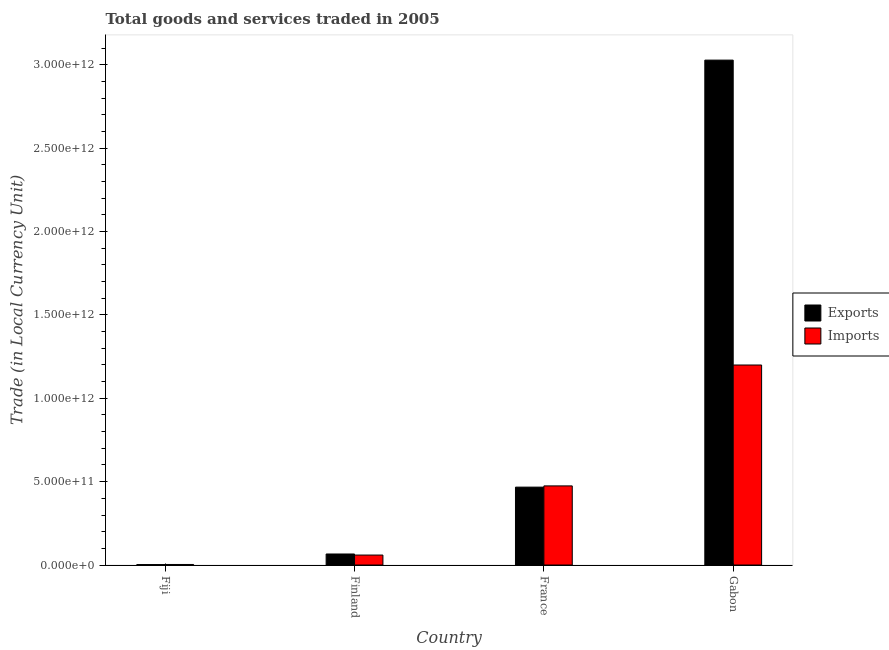Are the number of bars per tick equal to the number of legend labels?
Provide a succinct answer. Yes. Are the number of bars on each tick of the X-axis equal?
Give a very brief answer. Yes. How many bars are there on the 4th tick from the left?
Your answer should be compact. 2. How many bars are there on the 3rd tick from the right?
Your answer should be compact. 2. What is the label of the 4th group of bars from the left?
Your response must be concise. Gabon. In how many cases, is the number of bars for a given country not equal to the number of legend labels?
Make the answer very short. 0. What is the imports of goods and services in Finland?
Your answer should be compact. 5.98e+1. Across all countries, what is the maximum imports of goods and services?
Your answer should be compact. 1.20e+12. Across all countries, what is the minimum imports of goods and services?
Provide a succinct answer. 3.31e+09. In which country was the export of goods and services maximum?
Provide a short and direct response. Gabon. In which country was the export of goods and services minimum?
Your answer should be very brief. Fiji. What is the total imports of goods and services in the graph?
Provide a succinct answer. 1.74e+12. What is the difference between the imports of goods and services in Fiji and that in Gabon?
Your answer should be very brief. -1.20e+12. What is the difference between the export of goods and services in Gabon and the imports of goods and services in Finland?
Your response must be concise. 2.97e+12. What is the average export of goods and services per country?
Keep it short and to the point. 8.91e+11. What is the difference between the export of goods and services and imports of goods and services in Fiji?
Your answer should be compact. -6.10e+08. In how many countries, is the imports of goods and services greater than 1800000000000 LCU?
Make the answer very short. 0. What is the ratio of the export of goods and services in France to that in Gabon?
Give a very brief answer. 0.15. What is the difference between the highest and the second highest export of goods and services?
Make the answer very short. 2.56e+12. What is the difference between the highest and the lowest imports of goods and services?
Make the answer very short. 1.20e+12. What does the 1st bar from the left in Finland represents?
Offer a terse response. Exports. What does the 2nd bar from the right in Gabon represents?
Your answer should be very brief. Exports. How many bars are there?
Make the answer very short. 8. Are all the bars in the graph horizontal?
Keep it short and to the point. No. What is the difference between two consecutive major ticks on the Y-axis?
Give a very brief answer. 5.00e+11. Are the values on the major ticks of Y-axis written in scientific E-notation?
Your answer should be compact. Yes. Does the graph contain any zero values?
Provide a short and direct response. No. Does the graph contain grids?
Provide a succinct answer. No. Where does the legend appear in the graph?
Your answer should be very brief. Center right. How many legend labels are there?
Keep it short and to the point. 2. What is the title of the graph?
Provide a short and direct response. Total goods and services traded in 2005. Does "Domestic liabilities" appear as one of the legend labels in the graph?
Make the answer very short. No. What is the label or title of the X-axis?
Provide a succinct answer. Country. What is the label or title of the Y-axis?
Your answer should be very brief. Trade (in Local Currency Unit). What is the Trade (in Local Currency Unit) of Exports in Fiji?
Make the answer very short. 2.70e+09. What is the Trade (in Local Currency Unit) in Imports in Fiji?
Provide a short and direct response. 3.31e+09. What is the Trade (in Local Currency Unit) of Exports in Finland?
Keep it short and to the point. 6.62e+1. What is the Trade (in Local Currency Unit) in Imports in Finland?
Give a very brief answer. 5.98e+1. What is the Trade (in Local Currency Unit) of Exports in France?
Provide a succinct answer. 4.67e+11. What is the Trade (in Local Currency Unit) in Imports in France?
Ensure brevity in your answer.  4.75e+11. What is the Trade (in Local Currency Unit) of Exports in Gabon?
Your answer should be compact. 3.03e+12. What is the Trade (in Local Currency Unit) of Imports in Gabon?
Provide a short and direct response. 1.20e+12. Across all countries, what is the maximum Trade (in Local Currency Unit) in Exports?
Keep it short and to the point. 3.03e+12. Across all countries, what is the maximum Trade (in Local Currency Unit) in Imports?
Your answer should be compact. 1.20e+12. Across all countries, what is the minimum Trade (in Local Currency Unit) of Exports?
Ensure brevity in your answer.  2.70e+09. Across all countries, what is the minimum Trade (in Local Currency Unit) of Imports?
Make the answer very short. 3.31e+09. What is the total Trade (in Local Currency Unit) of Exports in the graph?
Keep it short and to the point. 3.56e+12. What is the total Trade (in Local Currency Unit) in Imports in the graph?
Your answer should be very brief. 1.74e+12. What is the difference between the Trade (in Local Currency Unit) of Exports in Fiji and that in Finland?
Offer a very short reply. -6.35e+1. What is the difference between the Trade (in Local Currency Unit) of Imports in Fiji and that in Finland?
Your answer should be very brief. -5.65e+1. What is the difference between the Trade (in Local Currency Unit) in Exports in Fiji and that in France?
Your answer should be compact. -4.65e+11. What is the difference between the Trade (in Local Currency Unit) of Imports in Fiji and that in France?
Provide a succinct answer. -4.71e+11. What is the difference between the Trade (in Local Currency Unit) of Exports in Fiji and that in Gabon?
Offer a very short reply. -3.03e+12. What is the difference between the Trade (in Local Currency Unit) in Imports in Fiji and that in Gabon?
Your answer should be compact. -1.20e+12. What is the difference between the Trade (in Local Currency Unit) in Exports in Finland and that in France?
Your answer should be compact. -4.01e+11. What is the difference between the Trade (in Local Currency Unit) in Imports in Finland and that in France?
Give a very brief answer. -4.15e+11. What is the difference between the Trade (in Local Currency Unit) of Exports in Finland and that in Gabon?
Provide a short and direct response. -2.96e+12. What is the difference between the Trade (in Local Currency Unit) in Imports in Finland and that in Gabon?
Provide a succinct answer. -1.14e+12. What is the difference between the Trade (in Local Currency Unit) in Exports in France and that in Gabon?
Your answer should be compact. -2.56e+12. What is the difference between the Trade (in Local Currency Unit) in Imports in France and that in Gabon?
Make the answer very short. -7.25e+11. What is the difference between the Trade (in Local Currency Unit) of Exports in Fiji and the Trade (in Local Currency Unit) of Imports in Finland?
Your response must be concise. -5.71e+1. What is the difference between the Trade (in Local Currency Unit) in Exports in Fiji and the Trade (in Local Currency Unit) in Imports in France?
Offer a terse response. -4.72e+11. What is the difference between the Trade (in Local Currency Unit) in Exports in Fiji and the Trade (in Local Currency Unit) in Imports in Gabon?
Your answer should be very brief. -1.20e+12. What is the difference between the Trade (in Local Currency Unit) of Exports in Finland and the Trade (in Local Currency Unit) of Imports in France?
Give a very brief answer. -4.08e+11. What is the difference between the Trade (in Local Currency Unit) in Exports in Finland and the Trade (in Local Currency Unit) in Imports in Gabon?
Provide a short and direct response. -1.13e+12. What is the difference between the Trade (in Local Currency Unit) in Exports in France and the Trade (in Local Currency Unit) in Imports in Gabon?
Provide a succinct answer. -7.33e+11. What is the average Trade (in Local Currency Unit) of Exports per country?
Make the answer very short. 8.91e+11. What is the average Trade (in Local Currency Unit) in Imports per country?
Give a very brief answer. 4.34e+11. What is the difference between the Trade (in Local Currency Unit) of Exports and Trade (in Local Currency Unit) of Imports in Fiji?
Offer a terse response. -6.10e+08. What is the difference between the Trade (in Local Currency Unit) of Exports and Trade (in Local Currency Unit) of Imports in Finland?
Make the answer very short. 6.38e+09. What is the difference between the Trade (in Local Currency Unit) of Exports and Trade (in Local Currency Unit) of Imports in France?
Your response must be concise. -7.34e+09. What is the difference between the Trade (in Local Currency Unit) of Exports and Trade (in Local Currency Unit) of Imports in Gabon?
Offer a very short reply. 1.83e+12. What is the ratio of the Trade (in Local Currency Unit) of Exports in Fiji to that in Finland?
Make the answer very short. 0.04. What is the ratio of the Trade (in Local Currency Unit) in Imports in Fiji to that in Finland?
Offer a very short reply. 0.06. What is the ratio of the Trade (in Local Currency Unit) of Exports in Fiji to that in France?
Your answer should be very brief. 0.01. What is the ratio of the Trade (in Local Currency Unit) of Imports in Fiji to that in France?
Give a very brief answer. 0.01. What is the ratio of the Trade (in Local Currency Unit) in Exports in Fiji to that in Gabon?
Offer a very short reply. 0. What is the ratio of the Trade (in Local Currency Unit) of Imports in Fiji to that in Gabon?
Make the answer very short. 0. What is the ratio of the Trade (in Local Currency Unit) in Exports in Finland to that in France?
Make the answer very short. 0.14. What is the ratio of the Trade (in Local Currency Unit) of Imports in Finland to that in France?
Make the answer very short. 0.13. What is the ratio of the Trade (in Local Currency Unit) in Exports in Finland to that in Gabon?
Make the answer very short. 0.02. What is the ratio of the Trade (in Local Currency Unit) in Imports in Finland to that in Gabon?
Make the answer very short. 0.05. What is the ratio of the Trade (in Local Currency Unit) of Exports in France to that in Gabon?
Offer a very short reply. 0.15. What is the ratio of the Trade (in Local Currency Unit) of Imports in France to that in Gabon?
Give a very brief answer. 0.4. What is the difference between the highest and the second highest Trade (in Local Currency Unit) in Exports?
Give a very brief answer. 2.56e+12. What is the difference between the highest and the second highest Trade (in Local Currency Unit) in Imports?
Offer a terse response. 7.25e+11. What is the difference between the highest and the lowest Trade (in Local Currency Unit) in Exports?
Your response must be concise. 3.03e+12. What is the difference between the highest and the lowest Trade (in Local Currency Unit) of Imports?
Ensure brevity in your answer.  1.20e+12. 